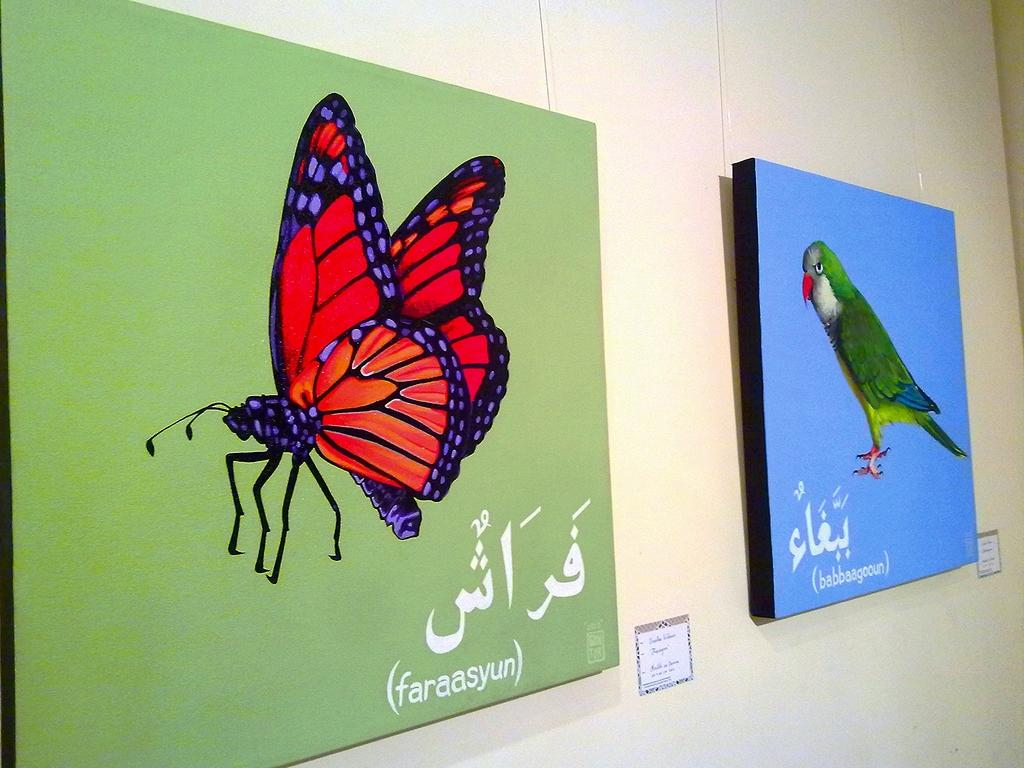What is hanging on the wall in the image? There are photo frames on the wall. What types of images are in the photo frames? The photo frames contain images of a butterfly and a parrot. Are there any words or text in the photo frames? Yes, the photo frames contain text. Where is the nearest market to the location of the photo frames in the image? The image does not provide information about the location of the photo frames or the nearest market, so it cannot be determined from the image. 